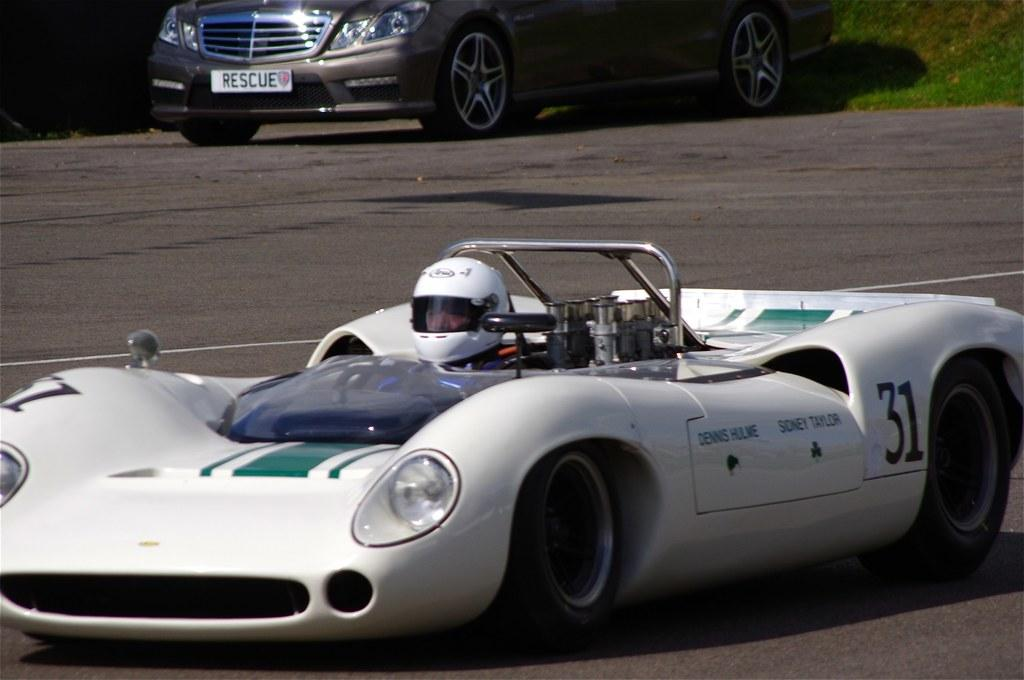What is the main subject of the image? There is a person riding a car in the image. Can you describe the setting of the image? There is another car in the background of the image. What type of spark can be seen coming from the person's hand in the image? There is no spark visible in the image; the person is simply riding a car. 